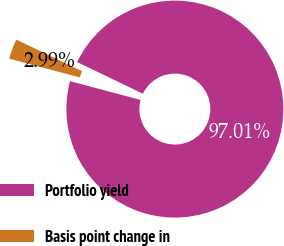<chart> <loc_0><loc_0><loc_500><loc_500><pie_chart><fcel>Portfolio yield<fcel>Basis point change in<nl><fcel>97.01%<fcel>2.99%<nl></chart> 